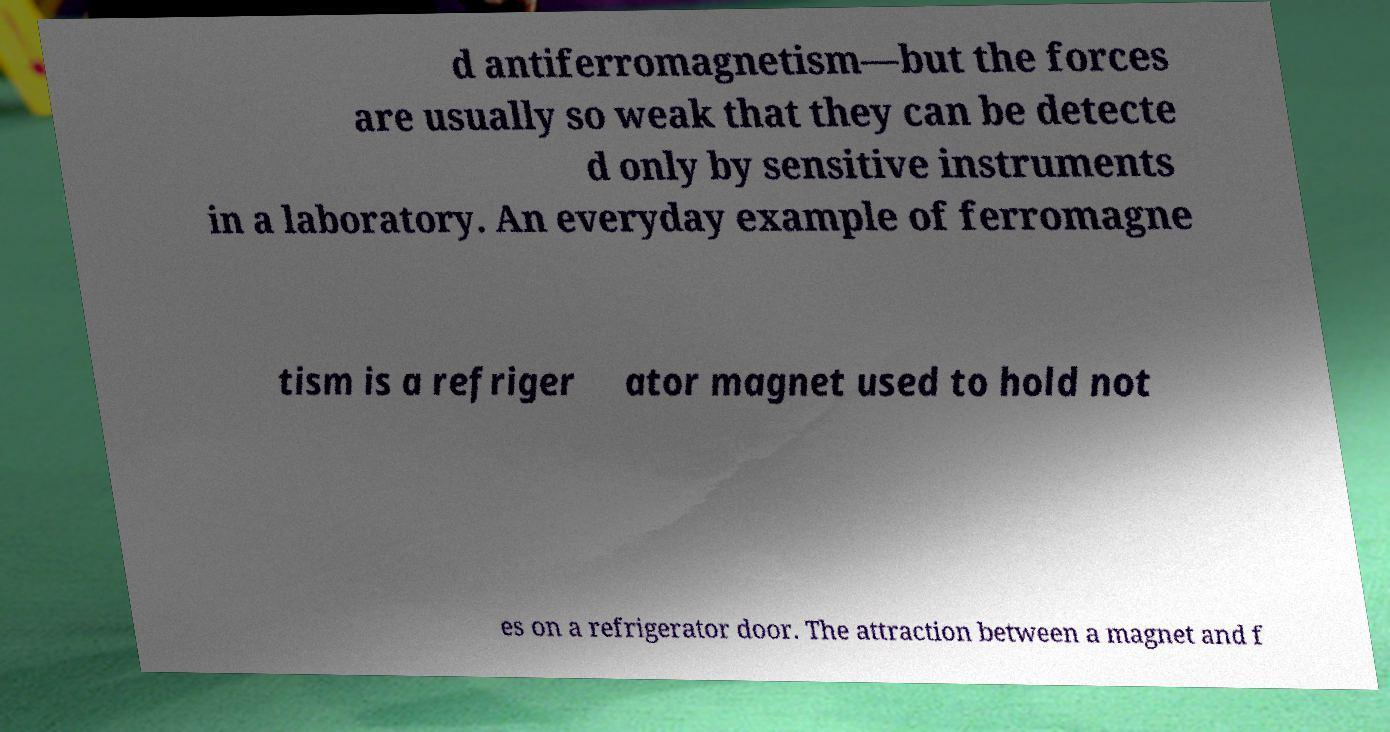Can you read and provide the text displayed in the image?This photo seems to have some interesting text. Can you extract and type it out for me? d antiferromagnetism—but the forces are usually so weak that they can be detecte d only by sensitive instruments in a laboratory. An everyday example of ferromagne tism is a refriger ator magnet used to hold not es on a refrigerator door. The attraction between a magnet and f 